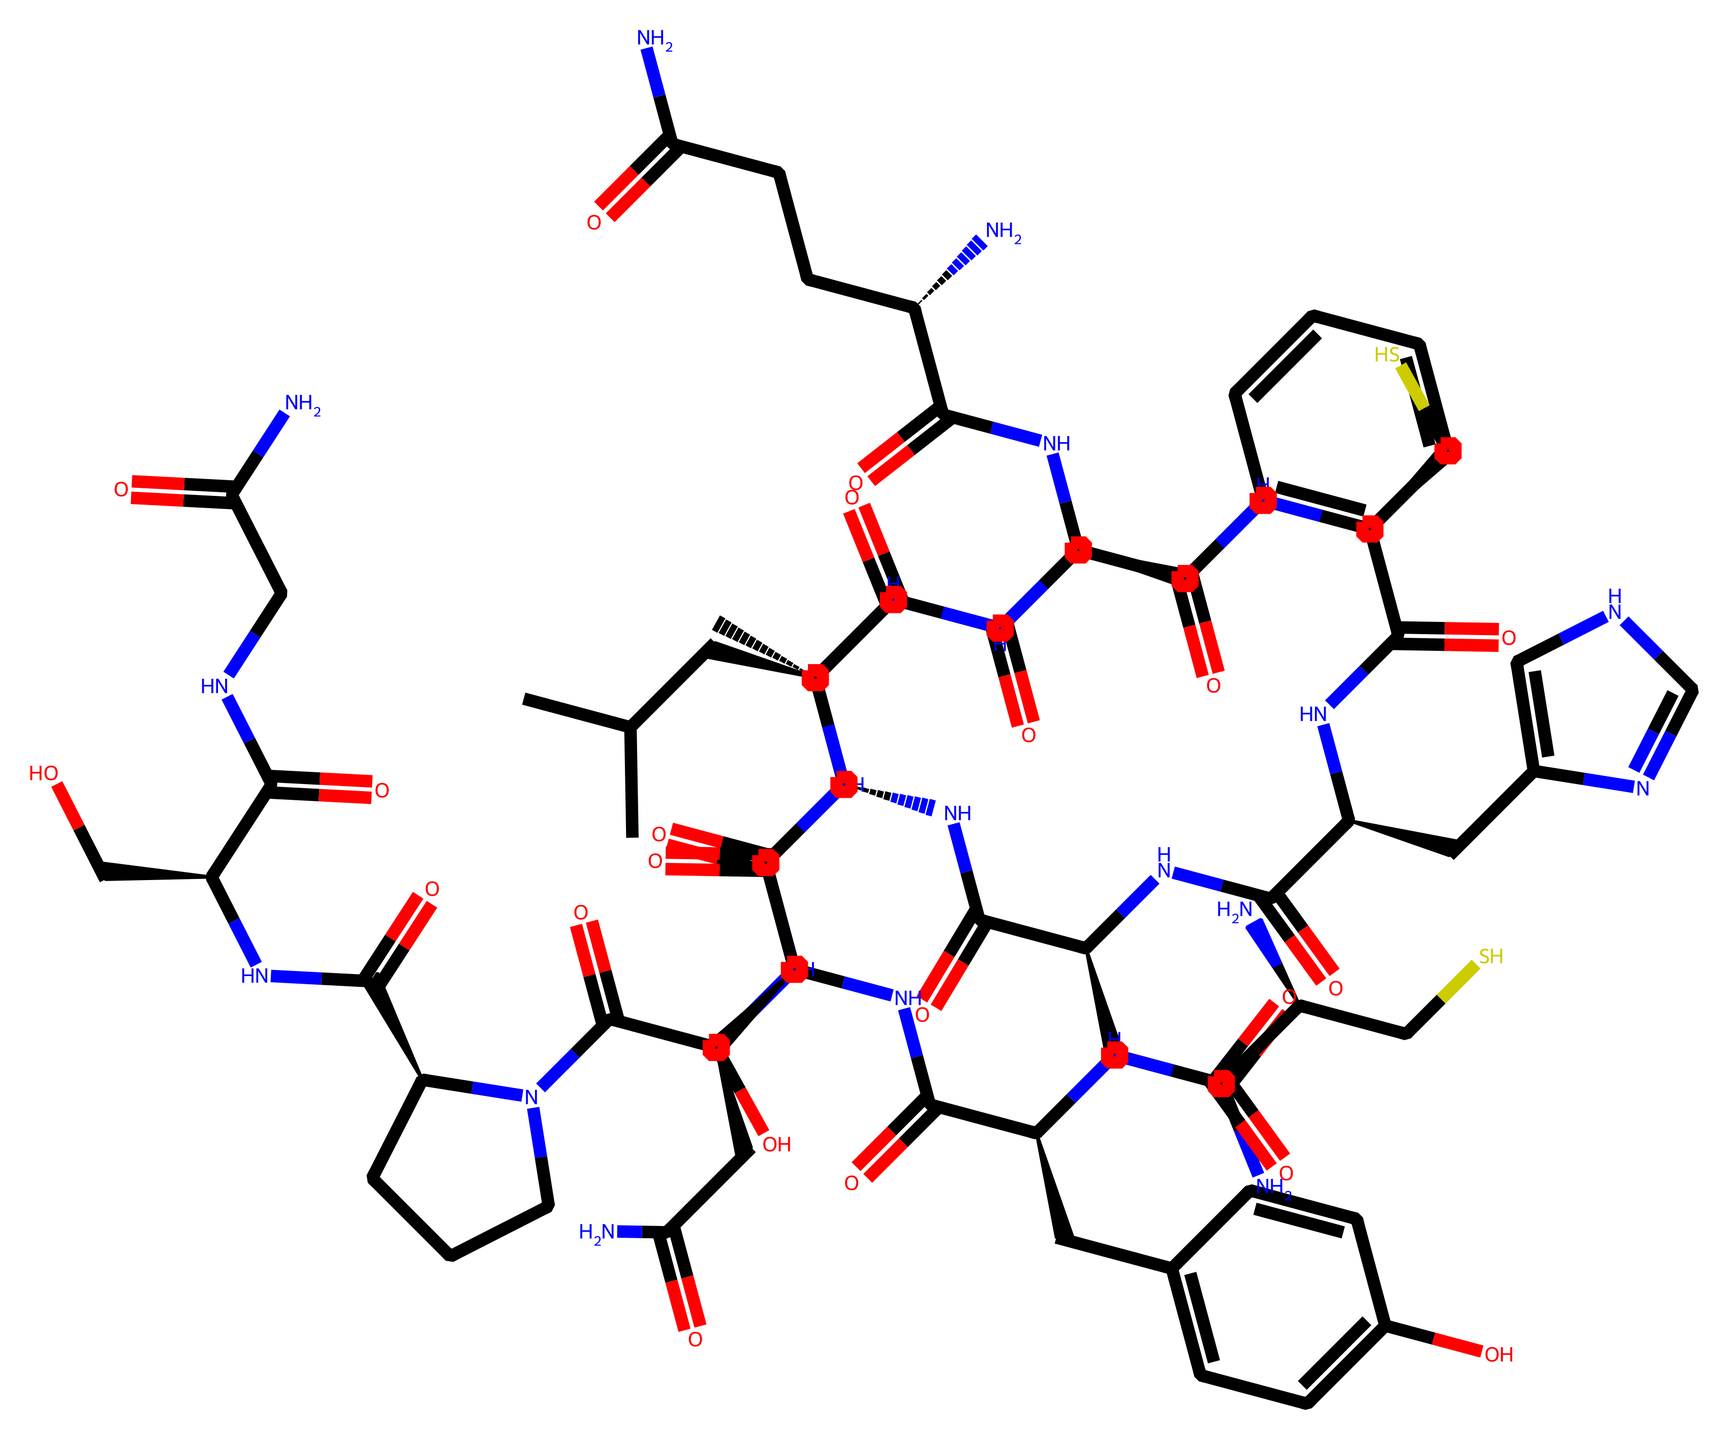how many amino acids are present in oxytocin? The SMILES representation of oxytocin corresponds to a peptide structure, and by closely examining the sequence, we can identify the number of amino acid residues listed. Oxytocin typically comprises nine amino acids.
Answer: nine what type of bonding predominates in oxytocin's structure? The structure represented denotes several types of bonds, but the predominant type is peptide bonds that link the amino acids together in the chain. These exist between the nitrogen and carbon atoms located throughout the SMILES.
Answer: peptide bonds which part of the molecule is responsible for its hormonal function? The specific sequence of amino acids, particularly those that form the active site, is crucial for oxytocin's binding to its receptors, which mediates its hormonal action in the body. Analyzing the SMILES shows the positions of side chains affecting this function.
Answer: specific amino acid sequence is there a functional group that indicates the molecule is a peptide? The presence of -CONH- (amide) groups indicates that this molecule is a peptide, highlighting substructures where the amino acids are connected. The SMILES shows multiple instances of these amide linkages.
Answer: -CONH- what is the overall charge of oxytocin at physiological pH? Examining the charged side groups within the structure is essential for determining the overall charge. Typically, oxytocin contains polar groups but predominantly remains neutral due to the balance of its amino acids at physiological pH.
Answer: neutral how many rings are present in the oxytocin structure? Observing the SMILES representation reveals that there are cyclic structures that form part of the overall configuration. A detailed count of closed loops present in the representation indicates that there are two rings.
Answer: two which functional groups are likely to participate in hydrogen bonding? The presence of amino (-NH2) groups and carbonyl (=O) groups can participate in hydrogen bonding, as indicated in the structure by various amino acids and linking moieties present within the SMILES.
Answer: amino and carbonyl groups 